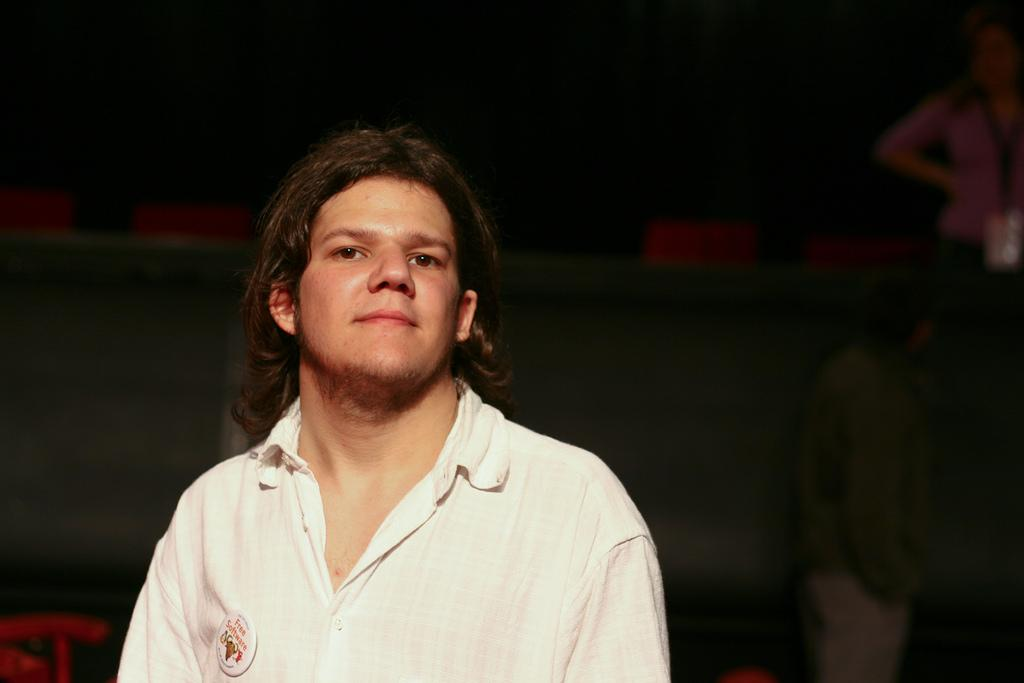Who is the main subject in the image? There is a man in the image. What is the man wearing? The man is wearing a shirt. Does the man have any distinguishing features or accessories? Yes, the man has a badge. What can be seen in the background of the image? The background of the image is dark, and there are people visible in the background. What is the grandmother's belief about the man in the image? There is no grandmother present in the image, so it is not possible to determine her belief about the man. 